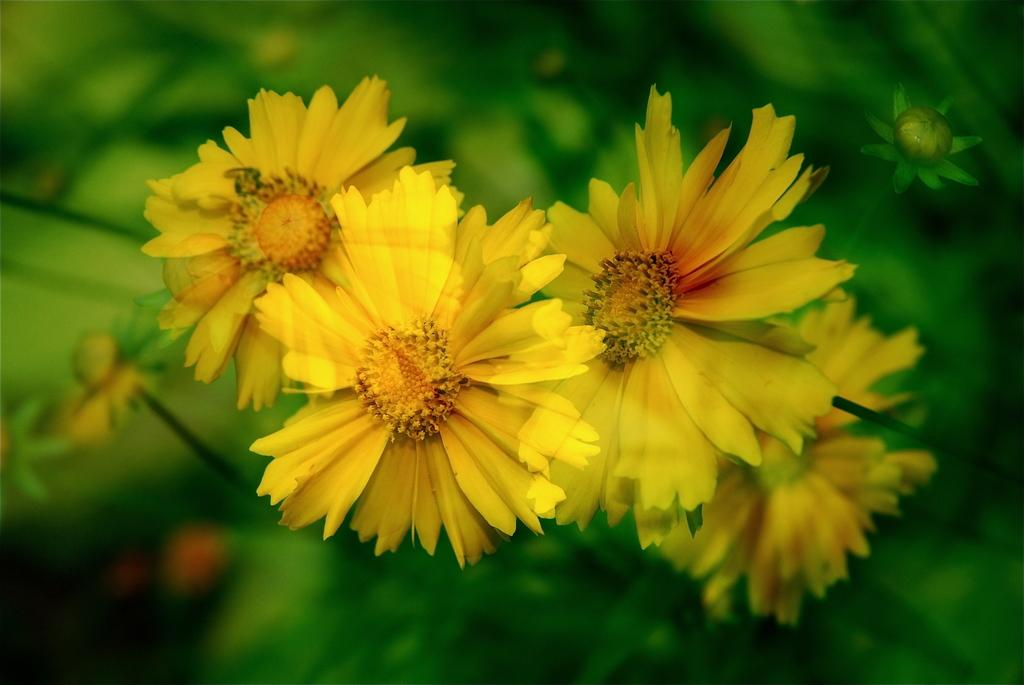What can be observed about the image's appearance? The image appears to be edited. What type of flora is present in the image? There are flowers in the image. What color is the background of the image? The background of the image is green. What position does the plantation hold in the image? There is no plantation present in the image. Can you describe the place where the flowers are located in the image? The flowers are located within the image, but the specific place cannot be determined from the provided facts. 